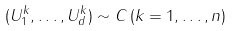Convert formula to latex. <formula><loc_0><loc_0><loc_500><loc_500>( U _ { 1 } ^ { k } , \dots , U _ { d } ^ { k } ) \sim C \, ( k = 1 , \dots , n )</formula> 